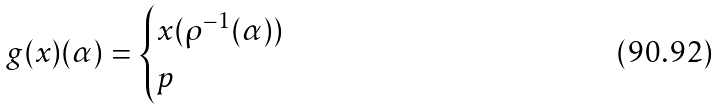<formula> <loc_0><loc_0><loc_500><loc_500>g ( x ) ( \alpha ) = \begin{cases} x ( \rho ^ { - 1 } ( \alpha ) ) & \\ p & \end{cases}</formula> 